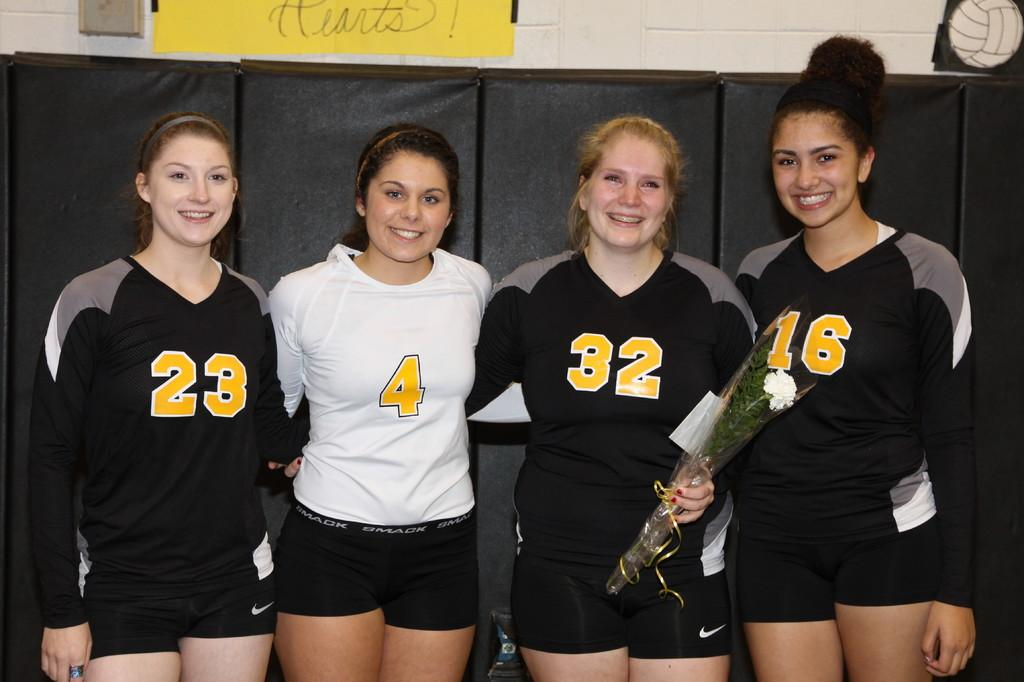<image>
Relay a brief, clear account of the picture shown. Girls are lined up in uniforms with numbers including 23,4,32, and 16. 